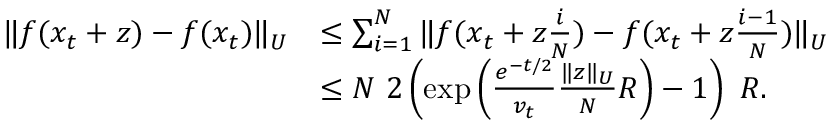<formula> <loc_0><loc_0><loc_500><loc_500>\begin{array} { r l } { \| f ( x _ { t } + z ) - f ( x _ { t } ) \| _ { U } } & { \leq \sum _ { i = 1 } ^ { N } \| f ( x _ { t } + z \frac { i } { N } ) - f ( x _ { t } + z \frac { i - 1 } { N } ) \| _ { U } } \\ & { \leq N 2 \left ( \exp \left ( \frac { e ^ { - t / 2 } } { v _ { t } } \frac { \| z \| _ { U } } { N } R \right ) - 1 \right ) R . } \end{array}</formula> 